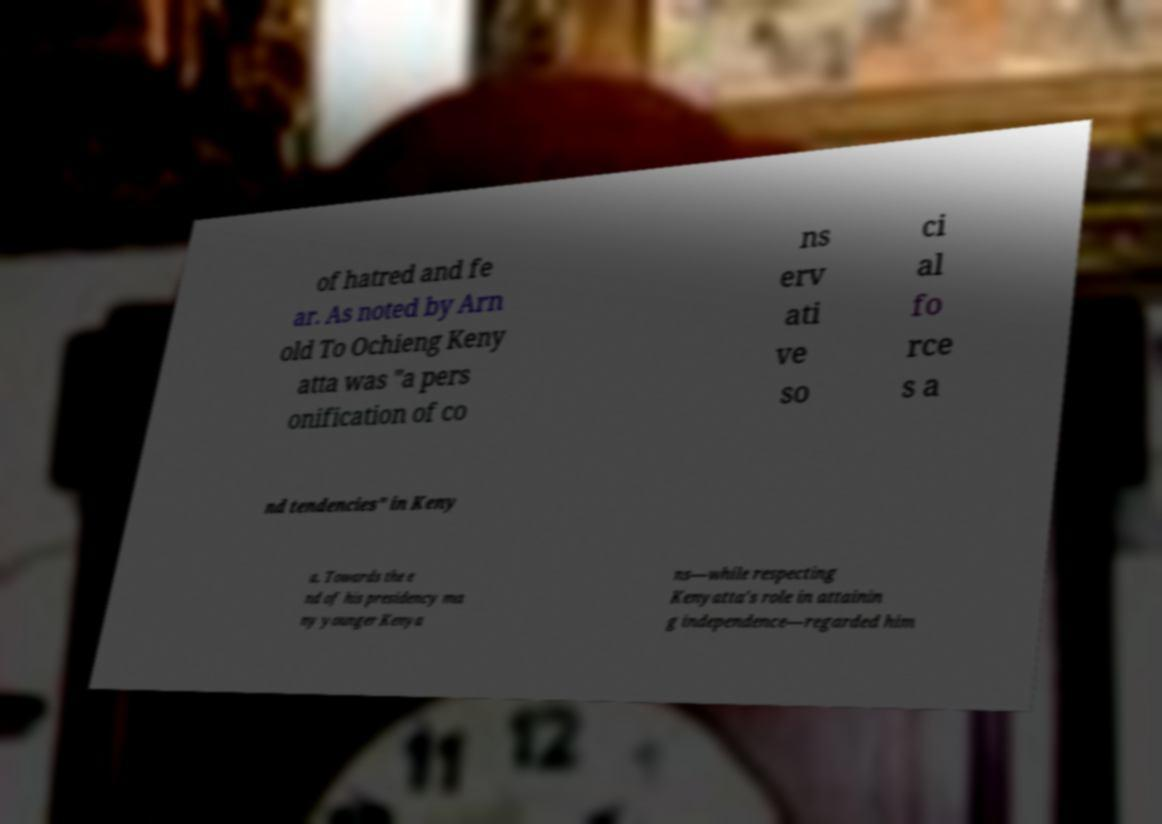Can you read and provide the text displayed in the image?This photo seems to have some interesting text. Can you extract and type it out for me? of hatred and fe ar. As noted by Arn old To Ochieng Keny atta was "a pers onification of co ns erv ati ve so ci al fo rce s a nd tendencies" in Keny a. Towards the e nd of his presidency ma ny younger Kenya ns—while respecting Kenyatta's role in attainin g independence—regarded him 